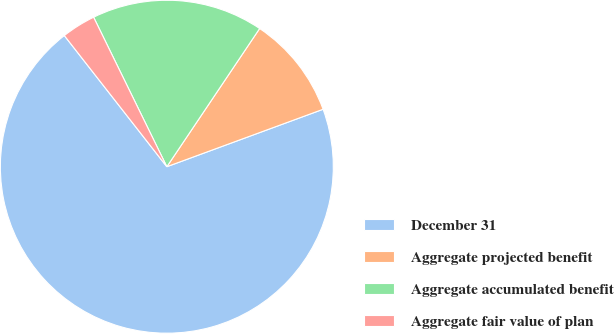<chart> <loc_0><loc_0><loc_500><loc_500><pie_chart><fcel>December 31<fcel>Aggregate projected benefit<fcel>Aggregate accumulated benefit<fcel>Aggregate fair value of plan<nl><fcel>70.05%<fcel>9.98%<fcel>16.66%<fcel>3.31%<nl></chart> 